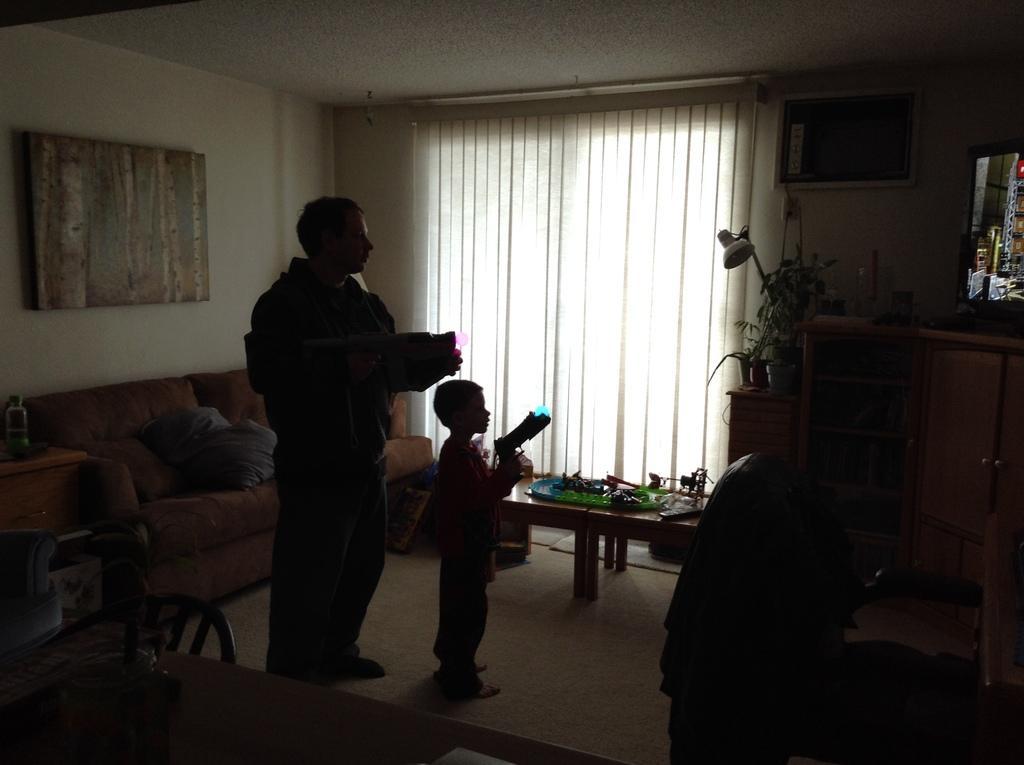In one or two sentences, can you explain what this image depicts? This is a picture inside of a house and there are two persons standing on the floor. And right side i can see a flower pot and there is a curtain on the middle And a photo frame attached to the wall on the left side , on the left side corner i can see a sofa set and there is a table ,on the left side corner. 